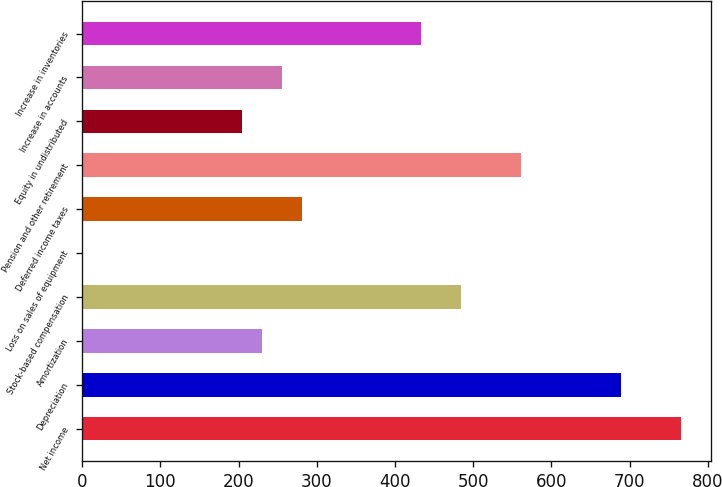Convert chart. <chart><loc_0><loc_0><loc_500><loc_500><bar_chart><fcel>Net income<fcel>Depreciation<fcel>Amortization<fcel>Stock-based compensation<fcel>Loss on sales of equipment<fcel>Deferred income taxes<fcel>Pension and other retirement<fcel>Equity in undistributed<fcel>Increase in accounts<fcel>Increase in inventories<nl><fcel>765.3<fcel>688.8<fcel>229.8<fcel>484.8<fcel>0.3<fcel>280.8<fcel>561.3<fcel>204.3<fcel>255.3<fcel>433.8<nl></chart> 